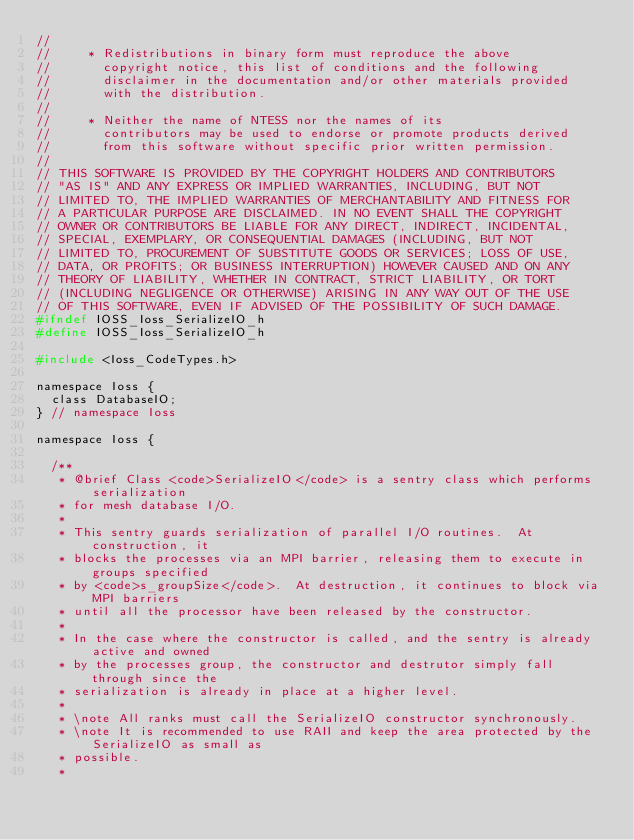Convert code to text. <code><loc_0><loc_0><loc_500><loc_500><_C_>//
//     * Redistributions in binary form must reproduce the above
//       copyright notice, this list of conditions and the following
//       disclaimer in the documentation and/or other materials provided
//       with the distribution.
//
//     * Neither the name of NTESS nor the names of its
//       contributors may be used to endorse or promote products derived
//       from this software without specific prior written permission.
//
// THIS SOFTWARE IS PROVIDED BY THE COPYRIGHT HOLDERS AND CONTRIBUTORS
// "AS IS" AND ANY EXPRESS OR IMPLIED WARRANTIES, INCLUDING, BUT NOT
// LIMITED TO, THE IMPLIED WARRANTIES OF MERCHANTABILITY AND FITNESS FOR
// A PARTICULAR PURPOSE ARE DISCLAIMED. IN NO EVENT SHALL THE COPYRIGHT
// OWNER OR CONTRIBUTORS BE LIABLE FOR ANY DIRECT, INDIRECT, INCIDENTAL,
// SPECIAL, EXEMPLARY, OR CONSEQUENTIAL DAMAGES (INCLUDING, BUT NOT
// LIMITED TO, PROCUREMENT OF SUBSTITUTE GOODS OR SERVICES; LOSS OF USE,
// DATA, OR PROFITS; OR BUSINESS INTERRUPTION) HOWEVER CAUSED AND ON ANY
// THEORY OF LIABILITY, WHETHER IN CONTRACT, STRICT LIABILITY, OR TORT
// (INCLUDING NEGLIGENCE OR OTHERWISE) ARISING IN ANY WAY OUT OF THE USE
// OF THIS SOFTWARE, EVEN IF ADVISED OF THE POSSIBILITY OF SUCH DAMAGE.
#ifndef IOSS_Ioss_SerializeIO_h
#define IOSS_Ioss_SerializeIO_h

#include <Ioss_CodeTypes.h>

namespace Ioss {
  class DatabaseIO;
} // namespace Ioss

namespace Ioss {

  /**
   * @brief Class <code>SerializeIO</code> is a sentry class which performs serialization
   * for mesh database I/O.
   *
   * This sentry guards serialization of parallel I/O routines.  At construction, it
   * blocks the processes via an MPI barrier, releasing them to execute in groups specified
   * by <code>s_groupSize</code>.  At destruction, it continues to block via MPI barriers
   * until all the processor have been released by the constructor.
   *
   * In the case where the constructor is called, and the sentry is already active and owned
   * by the processes group, the constructor and destrutor simply fall through since the
   * serialization is already in place at a higher level.
   *
   * \note All ranks must call the SerializeIO constructor synchronously.
   * \note It is recommended to use RAII and keep the area protected by the SerializeIO as small as
   * possible.
   *</code> 